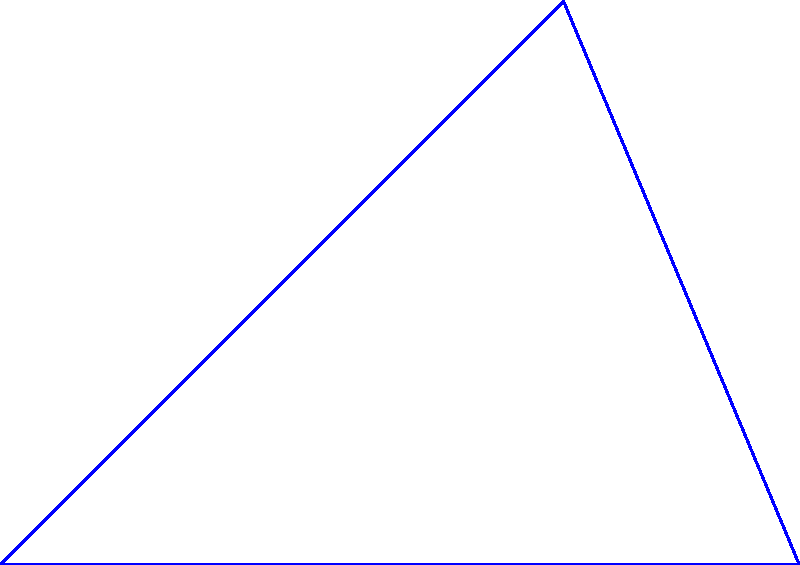In the QICI Engine, you need to rotate a sprite around its center by 45 degrees clockwise. If the sprite's initial position is at point A(2,0) on a circle with radius 2 and center at O(0,0), what will be the coordinates of the sprite's new position (point B) after rotation? To solve this problem, let's follow these steps:

1. Understand the initial setup:
   - The sprite is at point A(2,0) on a circle with radius 2.
   - The center of rotation is O(0,0).
   - We need to rotate 45 degrees clockwise.

2. Recall the rotation formula:
   For a point (x,y) rotated by an angle θ counterclockwise:
   $x' = x \cos θ - y \sin θ$
   $y' = x \sin θ + y \cos θ$

3. Adjust for clockwise rotation:
   For clockwise rotation, we use -θ:
   $x' = x \cos(-θ) - y \sin(-θ) = x \cos θ + y \sin θ$
   $y' = x \sin(-θ) + y \cos(-θ) = -x \sin θ + y \cos θ$

4. Calculate $\cos 45°$ and $\sin 45°$:
   $\cos 45° = \sin 45° = \frac{1}{\sqrt{2}} \approx 0.7071$

5. Apply the rotation formula:
   $x' = 2 \cos 45° + 0 \sin 45° = 2 \cdot \frac{1}{\sqrt{2}} = \sqrt{2} \approx 1.4142$
   $y' = -2 \sin 45° + 0 \cos 45° = -2 \cdot \frac{1}{\sqrt{2}} = -\sqrt{2} \approx -1.4142$

6. The y-coordinate is negative because we rotated clockwise. To get the final position, we need to take its absolute value.

Therefore, the new position of the sprite (point B) after rotation will be approximately (1.41, 1.41).
Answer: (1.41, 1.41) 